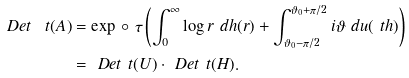<formula> <loc_0><loc_0><loc_500><loc_500>\ D e t _ { \ } t ( A ) & = \exp \, \circ \ \tau \left ( \int _ { 0 } ^ { \infty } \log r \ d h ( r ) + \int _ { \vartheta _ { 0 } - \pi / 2 } ^ { \vartheta _ { 0 } + \pi / 2 } i \vartheta \ d u ( \ t h ) \right ) \\ & = \ D e t _ { \ } t ( U ) \cdot \ D e t _ { \ } t ( H ) .</formula> 